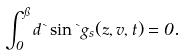Convert formula to latex. <formula><loc_0><loc_0><loc_500><loc_500>\int _ { 0 } ^ { \pi } d \theta \sin \theta { g } _ { s } ( z , v , t ) = 0 .</formula> 